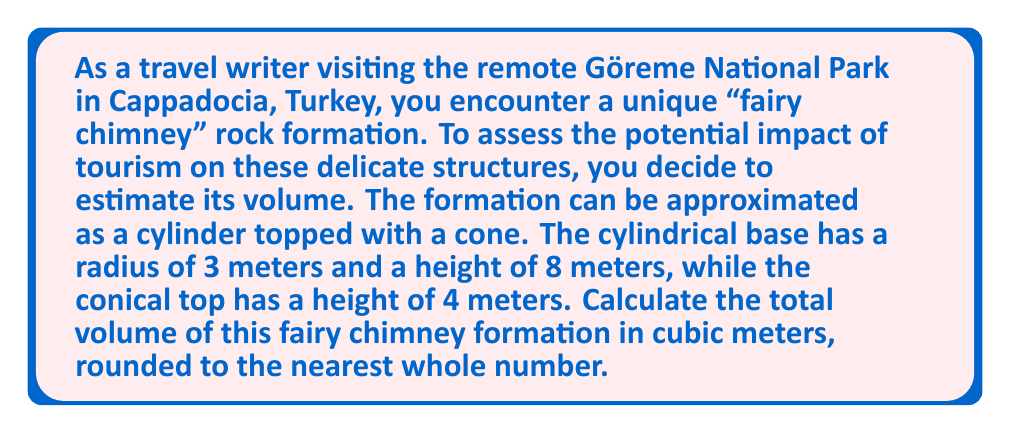Can you answer this question? To calculate the total volume of the fairy chimney formation, we need to sum the volumes of the cylindrical base and the conical top.

1. Volume of the cylindrical base:
   The formula for the volume of a cylinder is $V_{cylinder} = \pi r^2 h$
   Where $r$ is the radius and $h$ is the height
   $$V_{cylinder} = \pi \cdot 3^2 \cdot 8 = 72\pi \approx 226.19 \text{ m}^3$$

2. Volume of the conical top:
   The formula for the volume of a cone is $V_{cone} = \frac{1}{3}\pi r^2 h$
   Where $r$ is the radius of the base and $h$ is the height
   $$V_{cone} = \frac{1}{3} \cdot \pi \cdot 3^2 \cdot 4 = 12\pi \approx 37.70 \text{ m}^3$$

3. Total volume:
   $$V_{total} = V_{cylinder} + V_{cone} = 72\pi + 12\pi = 84\pi \approx 263.89 \text{ m}^3$$

4. Rounding to the nearest whole number:
   $$V_{total} \approx 264 \text{ m}^3$$
Answer: $264 \text{ m}^3$ 